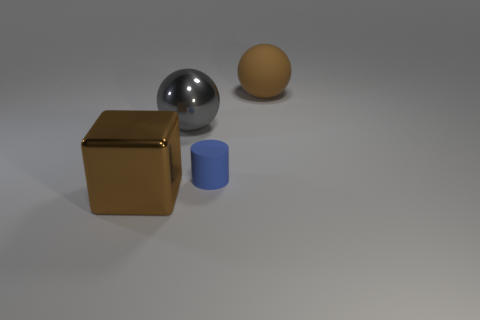Add 1 red rubber spheres. How many objects exist? 5 Subtract all cylinders. How many objects are left? 3 Add 3 big balls. How many big balls are left? 5 Add 3 large gray things. How many large gray things exist? 4 Subtract 0 green blocks. How many objects are left? 4 Subtract all blue matte things. Subtract all blue matte things. How many objects are left? 2 